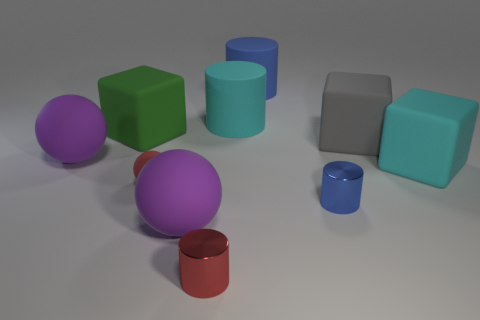Subtract all cubes. How many objects are left? 7 Add 3 large yellow cylinders. How many large yellow cylinders exist? 3 Subtract all cyan cylinders. How many cylinders are left? 3 Subtract all tiny red cylinders. How many cylinders are left? 3 Subtract 0 blue blocks. How many objects are left? 10 Subtract 2 cubes. How many cubes are left? 1 Subtract all blue blocks. Subtract all cyan cylinders. How many blocks are left? 3 Subtract all brown balls. How many red cylinders are left? 1 Subtract all big rubber cylinders. Subtract all small rubber things. How many objects are left? 7 Add 8 large purple spheres. How many large purple spheres are left? 10 